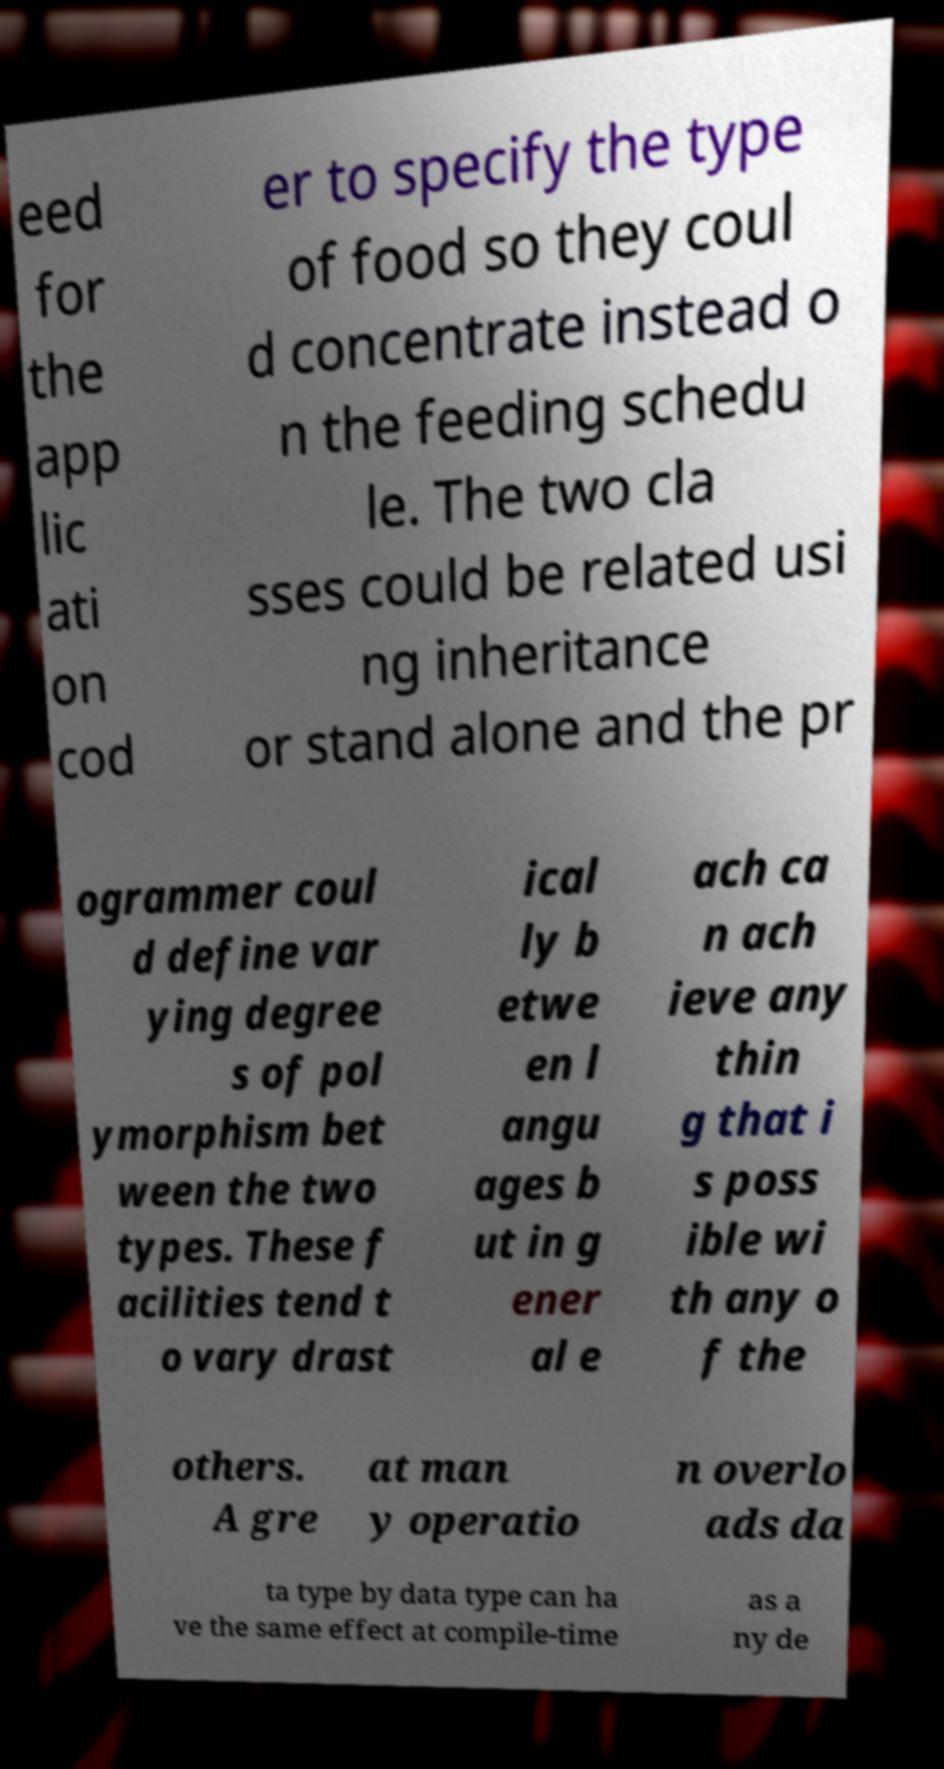Can you read and provide the text displayed in the image?This photo seems to have some interesting text. Can you extract and type it out for me? eed for the app lic ati on cod er to specify the type of food so they coul d concentrate instead o n the feeding schedu le. The two cla sses could be related usi ng inheritance or stand alone and the pr ogrammer coul d define var ying degree s of pol ymorphism bet ween the two types. These f acilities tend t o vary drast ical ly b etwe en l angu ages b ut in g ener al e ach ca n ach ieve any thin g that i s poss ible wi th any o f the others. A gre at man y operatio n overlo ads da ta type by data type can ha ve the same effect at compile-time as a ny de 